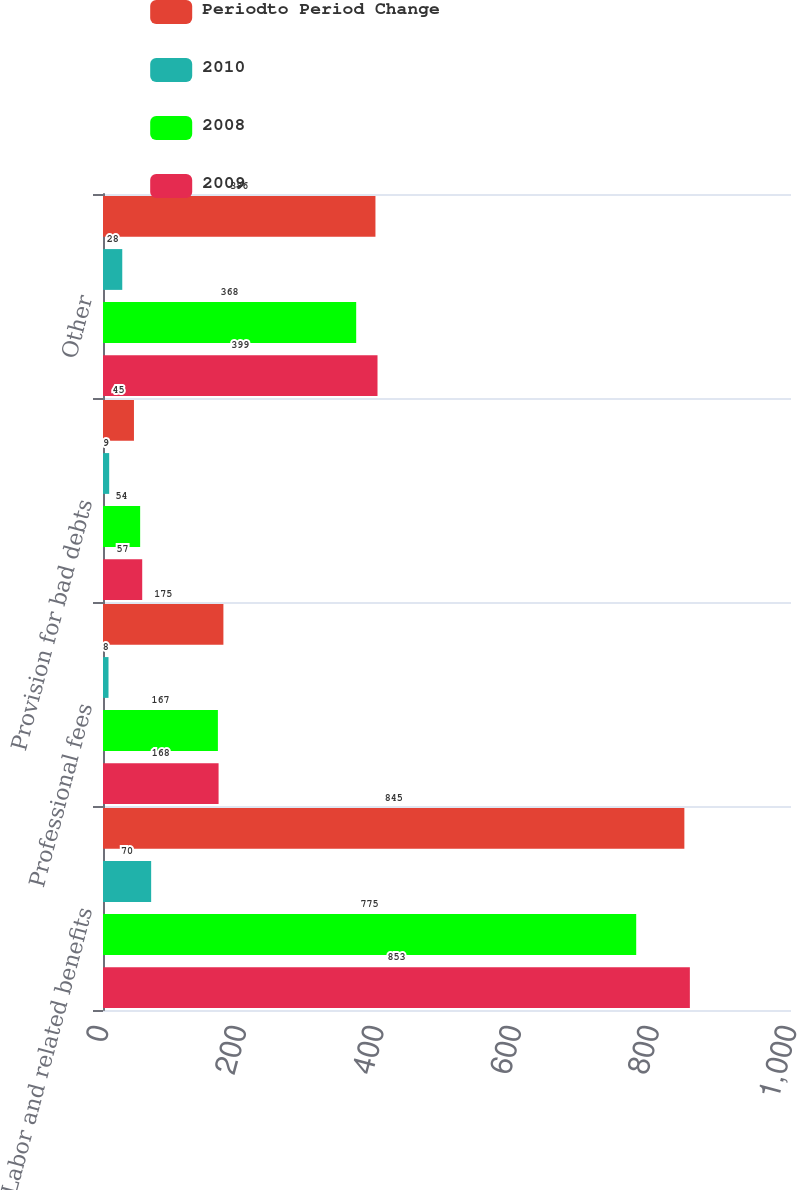Convert chart. <chart><loc_0><loc_0><loc_500><loc_500><stacked_bar_chart><ecel><fcel>Labor and related benefits<fcel>Professional fees<fcel>Provision for bad debts<fcel>Other<nl><fcel>Periodto Period Change<fcel>845<fcel>175<fcel>45<fcel>396<nl><fcel>2010<fcel>70<fcel>8<fcel>9<fcel>28<nl><fcel>2008<fcel>775<fcel>167<fcel>54<fcel>368<nl><fcel>2009<fcel>853<fcel>168<fcel>57<fcel>399<nl></chart> 